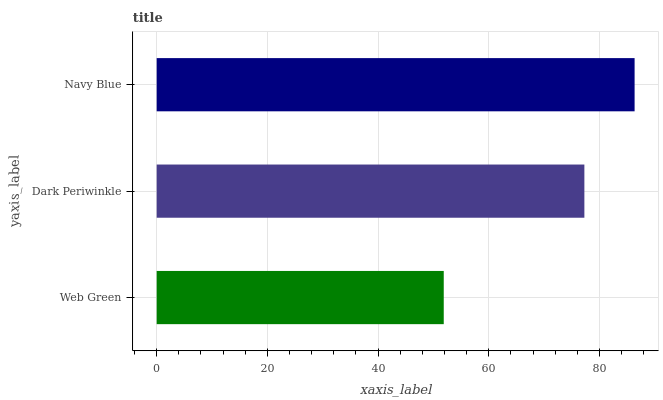Is Web Green the minimum?
Answer yes or no. Yes. Is Navy Blue the maximum?
Answer yes or no. Yes. Is Dark Periwinkle the minimum?
Answer yes or no. No. Is Dark Periwinkle the maximum?
Answer yes or no. No. Is Dark Periwinkle greater than Web Green?
Answer yes or no. Yes. Is Web Green less than Dark Periwinkle?
Answer yes or no. Yes. Is Web Green greater than Dark Periwinkle?
Answer yes or no. No. Is Dark Periwinkle less than Web Green?
Answer yes or no. No. Is Dark Periwinkle the high median?
Answer yes or no. Yes. Is Dark Periwinkle the low median?
Answer yes or no. Yes. Is Web Green the high median?
Answer yes or no. No. Is Navy Blue the low median?
Answer yes or no. No. 